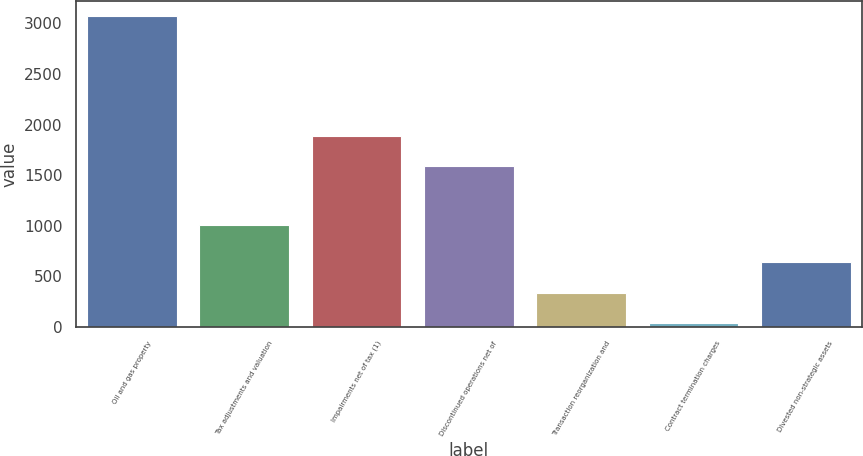Convert chart to OTSL. <chart><loc_0><loc_0><loc_500><loc_500><bar_chart><fcel>Oil and gas property<fcel>Tax adjustments and valuation<fcel>Impairments net of tax (1)<fcel>Discontinued operations net of<fcel>Transaction reorganization and<fcel>Contract termination charges<fcel>Divested non-strategic assets<nl><fcel>3068<fcel>1005<fcel>1891.3<fcel>1588<fcel>338.3<fcel>35<fcel>641.6<nl></chart> 